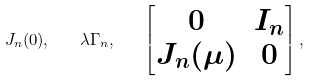Convert formula to latex. <formula><loc_0><loc_0><loc_500><loc_500>J _ { n } ( 0 ) , \quad \lambda \Gamma _ { n } , \quad \begin{bmatrix} 0 & I _ { n } \\ J _ { n } ( \mu ) & 0 \end{bmatrix} ,</formula> 